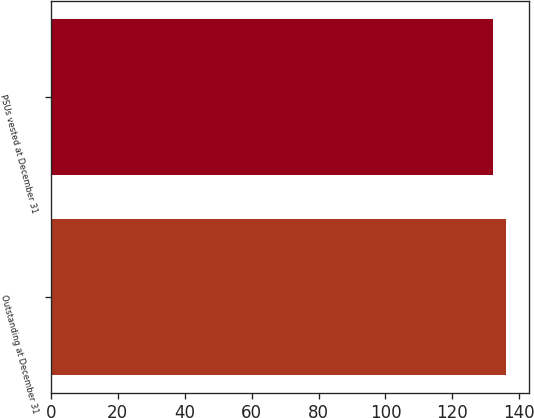<chart> <loc_0><loc_0><loc_500><loc_500><bar_chart><fcel>Outstanding at December 31<fcel>PSUs vested at December 31<nl><fcel>136<fcel>132<nl></chart> 